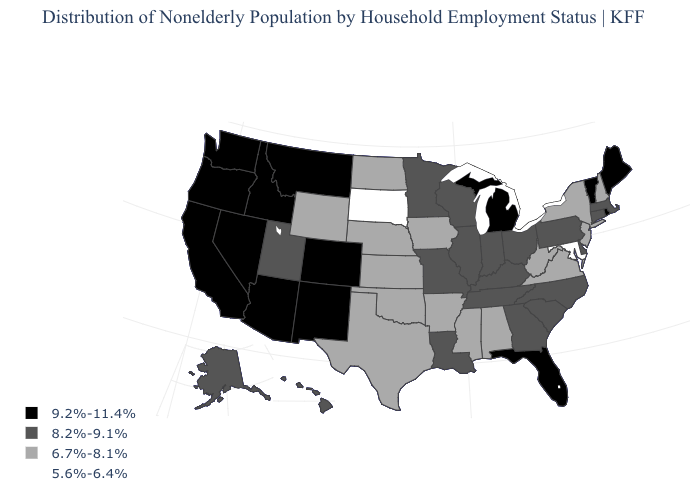Name the states that have a value in the range 5.6%-6.4%?
Write a very short answer. Maryland, South Dakota. Name the states that have a value in the range 9.2%-11.4%?
Answer briefly. Arizona, California, Colorado, Florida, Idaho, Maine, Michigan, Montana, Nevada, New Mexico, Oregon, Rhode Island, Vermont, Washington. Which states have the lowest value in the USA?
Answer briefly. Maryland, South Dakota. Which states have the lowest value in the West?
Be succinct. Wyoming. Does Arkansas have a higher value than South Dakota?
Be succinct. Yes. Name the states that have a value in the range 8.2%-9.1%?
Be succinct. Alaska, Connecticut, Delaware, Georgia, Hawaii, Illinois, Indiana, Kentucky, Louisiana, Massachusetts, Minnesota, Missouri, North Carolina, Ohio, Pennsylvania, South Carolina, Tennessee, Utah, Wisconsin. Name the states that have a value in the range 6.7%-8.1%?
Write a very short answer. Alabama, Arkansas, Iowa, Kansas, Mississippi, Nebraska, New Hampshire, New Jersey, New York, North Dakota, Oklahoma, Texas, Virginia, West Virginia, Wyoming. What is the value of Rhode Island?
Answer briefly. 9.2%-11.4%. Name the states that have a value in the range 9.2%-11.4%?
Keep it brief. Arizona, California, Colorado, Florida, Idaho, Maine, Michigan, Montana, Nevada, New Mexico, Oregon, Rhode Island, Vermont, Washington. What is the value of New Mexico?
Quick response, please. 9.2%-11.4%. Does the first symbol in the legend represent the smallest category?
Short answer required. No. What is the lowest value in the West?
Keep it brief. 6.7%-8.1%. Does South Carolina have a higher value than Nebraska?
Concise answer only. Yes. Which states have the lowest value in the West?
Concise answer only. Wyoming. Among the states that border Vermont , which have the highest value?
Give a very brief answer. Massachusetts. 